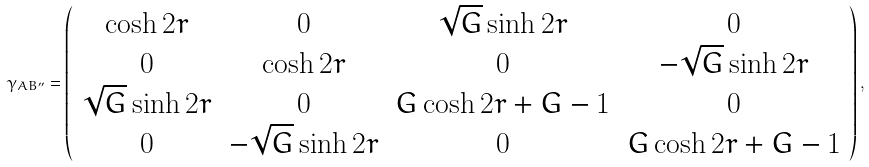<formula> <loc_0><loc_0><loc_500><loc_500>\gamma _ { A B ^ { \prime \prime } } = \left ( \begin{array} { c c c c } \cosh { 2 r } & 0 & \sqrt { G } \sinh { 2 r } & 0 \\ 0 & \cosh { 2 r } & 0 & - \sqrt { G } \sinh { 2 r } \\ \sqrt { G } \sinh { 2 r } & 0 & G \cosh { 2 r } + G - 1 & 0 \\ 0 & - \sqrt { G } \sinh { 2 r } & 0 & G \cosh { 2 r } + G - 1 \\ \end{array} \right ) ,</formula> 